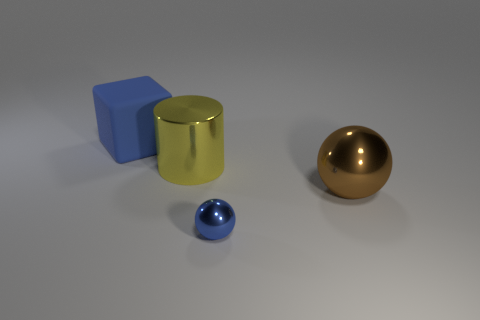Subtract all red cylinders. Subtract all yellow balls. How many cylinders are left? 1 Add 1 tiny blue metallic objects. How many objects exist? 5 Subtract all blocks. How many objects are left? 3 Subtract 1 yellow cylinders. How many objects are left? 3 Subtract all tiny purple cubes. Subtract all large metallic objects. How many objects are left? 2 Add 2 big yellow metal objects. How many big yellow metal objects are left? 3 Add 2 big yellow things. How many big yellow things exist? 3 